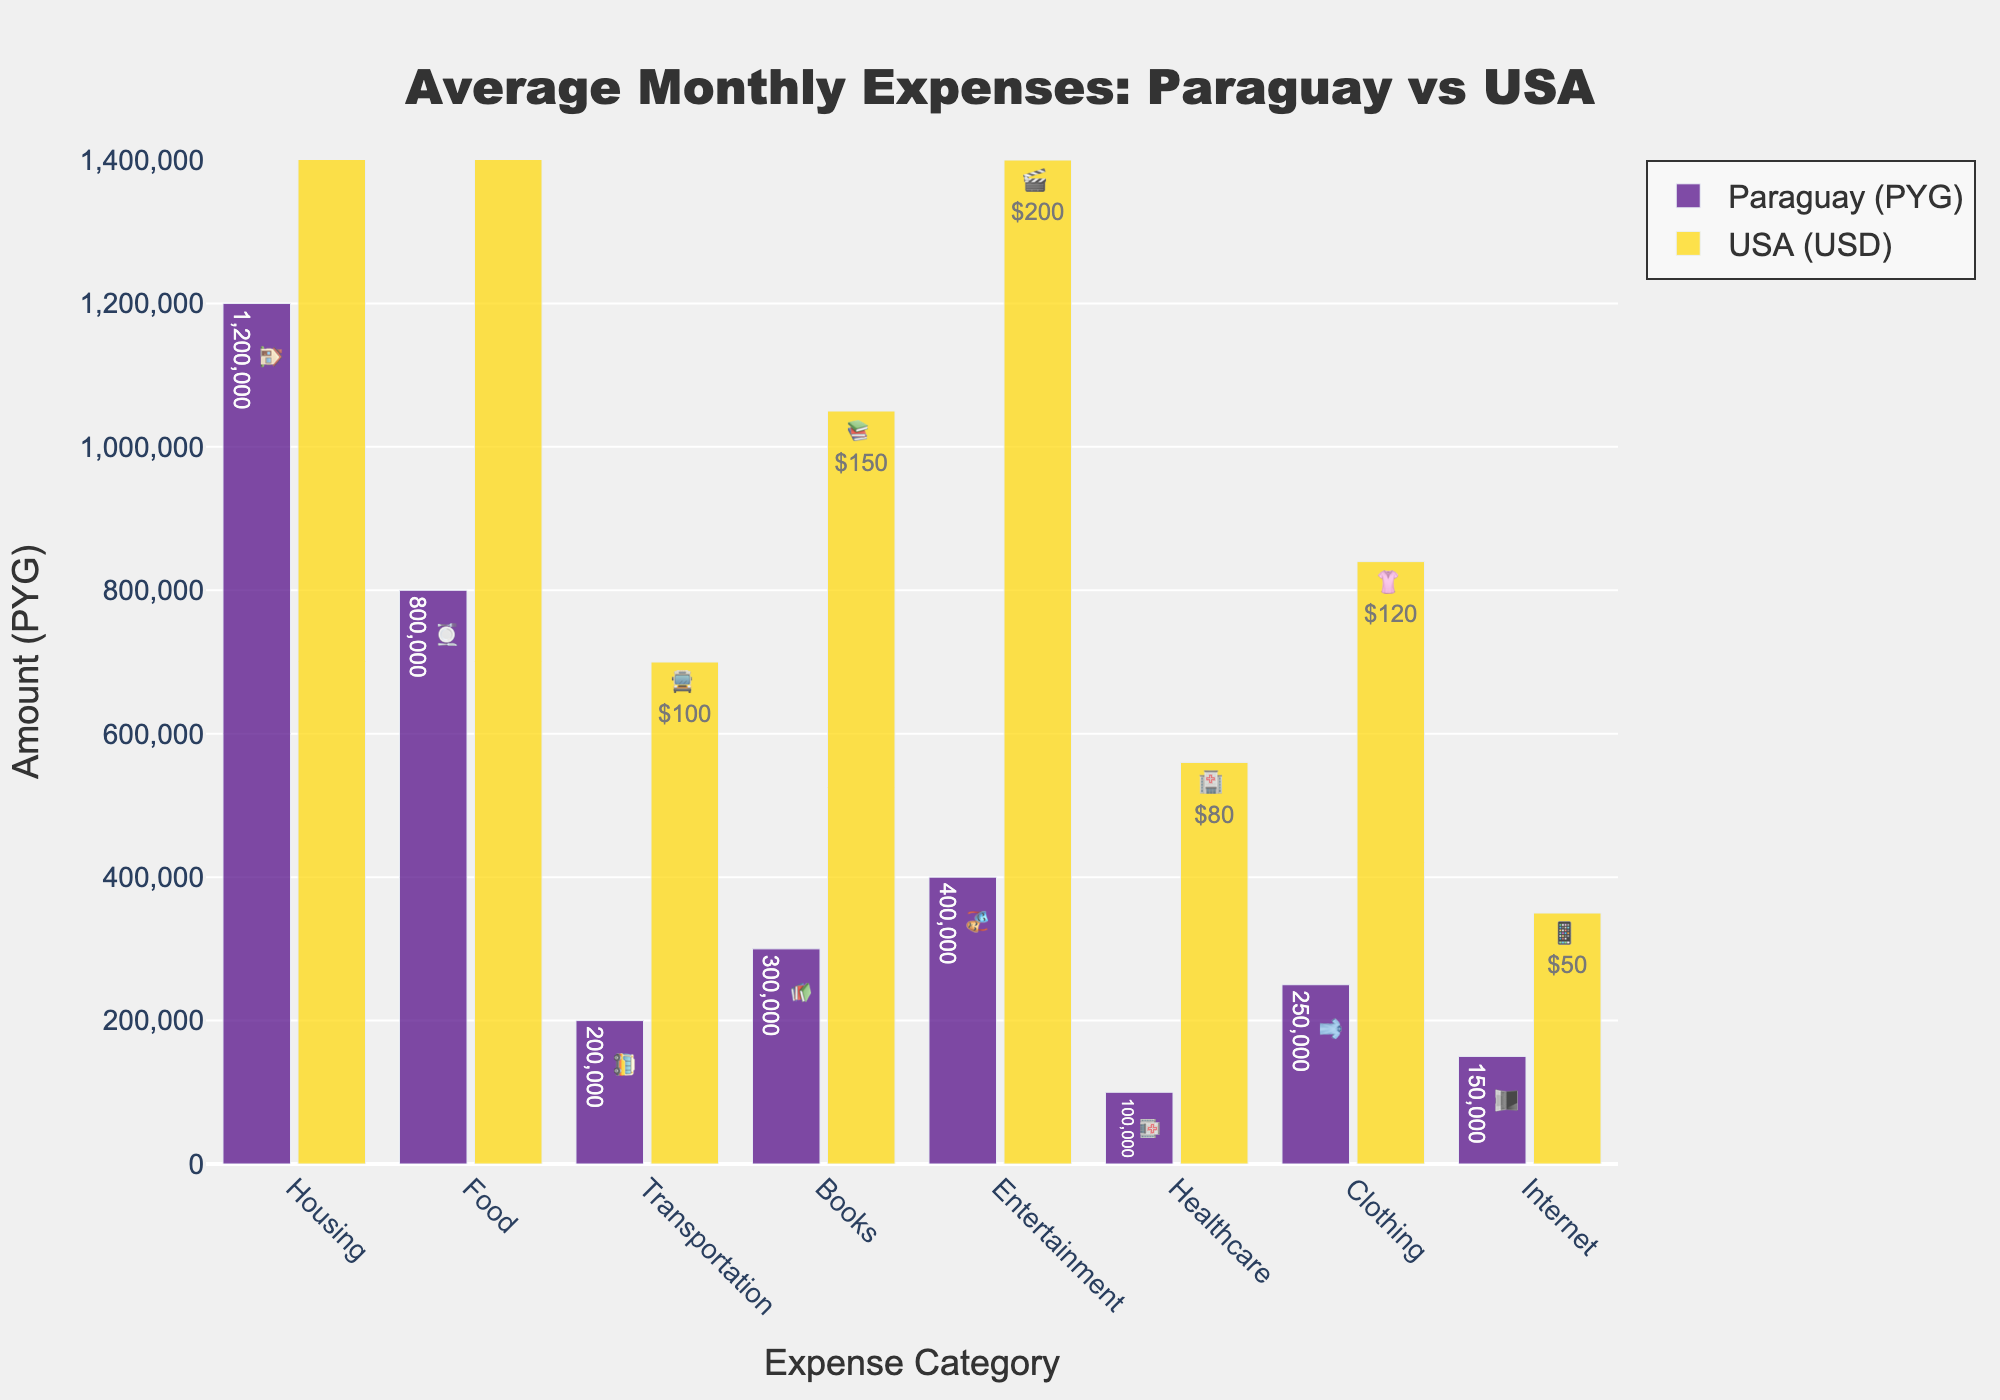What's the title of the chart? The title of the chart is located at the top and it provides an overview of what the chart is about.
Answer: Average Monthly Expenses: Paraguay vs USA In which category is the difference in expenses between Paraguay and the USA the greatest? By comparing the heights of the bars for both countries in each category, it's clear that the difference in Housing expenses is the greatest, with the USA having significantly higher expenses.
Answer: Housing What is the total expense for Food and Transportation in Paraguay? To find the total, add the Food expense and the Transportation expense for Paraguay. Food: 800,000 PYG + Transportation: 200,000 PYG = 1,000,000 PYG.
Answer: 1,000,000 PYG Which country spends more on Entertainment, and by how much? Compare the heights of the bars for Entertainment between the two countries. Paraguay spends 400,000 PYG while the USA spends 200 USD (which is 1,400,000 PYG when converted). Subtract the amounts: 1,400,000 - 400,000 = 1,000,000 PYG.
Answer: USA by 1,000,000 PYG What is the average expense for Clothing and Healthcare in the USA? Add the Clothing and Healthcare expenses for the USA, then divide by 2. Clothing: 120 USD + Healthcare: 80 USD = 200 USD. Average: 200 / 2 = 100 USD.
Answer: 100 USD In which category do both countries have the lowest expenses? The bar with the lowest value in both countries represents Healthcare.
Answer: Healthcare How much more does a student in the USA spend on Books compared to a student in Paraguay? Find the difference between the expenses on Books in the USA and Paraguay. USA: 150 USD (1,050,000 PYG) - Paraguay: 300,000 PYG. 1,050,000 - 300,000 = 750,000 PYG.
Answer: 750,000 PYG Which category has similar expenses in both countries? Compare the pairs of bars. The Internet expenses are relatively close, with Paraguay at 150,000 PYG and the USA at 50 USD (350,000 PYG).
Answer: Internet What is the total expense for all categories in Paraguay? Sum up the expenses for all categories in Paraguay: Housing: 1,200,000 + Food: 800,000 + Transportation: 200,000 + Books: 300,000 + Entertainment: 400,000 + Healthcare: 100,000 + Clothing: 250,000 + Internet: 150,000 = 3,400,000 PYG.
Answer: 3,400,000 PYG 